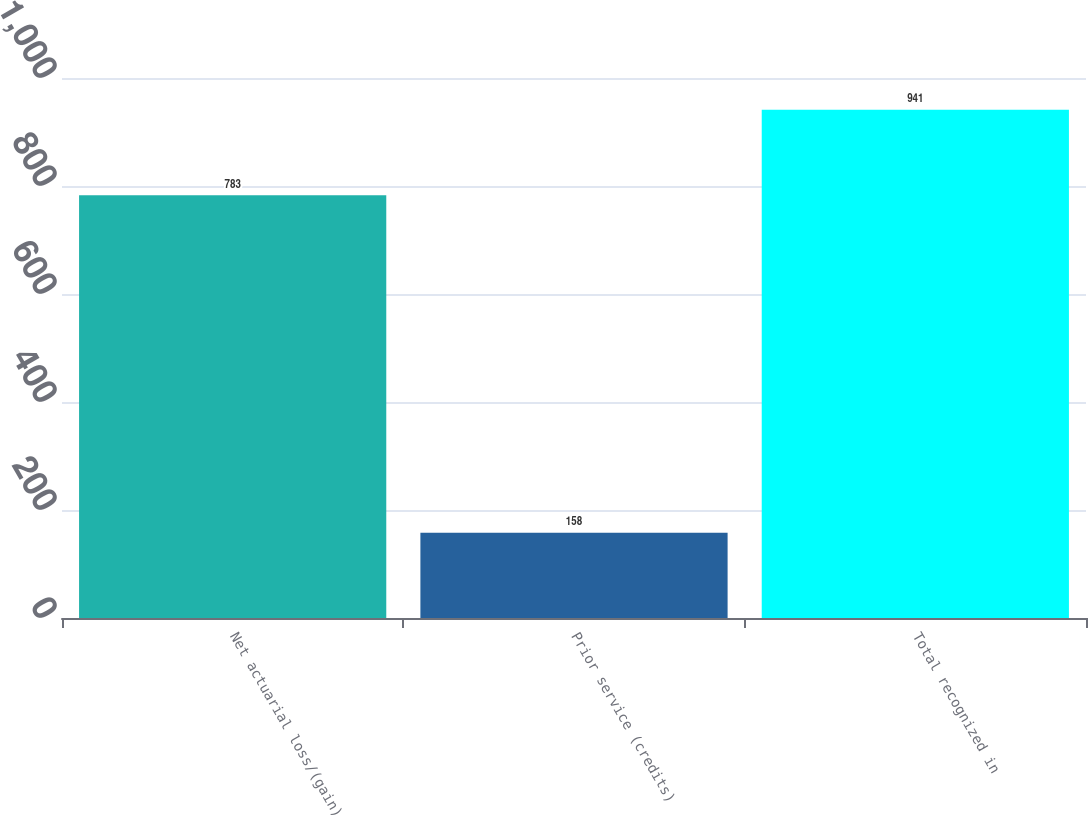<chart> <loc_0><loc_0><loc_500><loc_500><bar_chart><fcel>Net actuarial loss/(gain)<fcel>Prior service (credits)<fcel>Total recognized in<nl><fcel>783<fcel>158<fcel>941<nl></chart> 